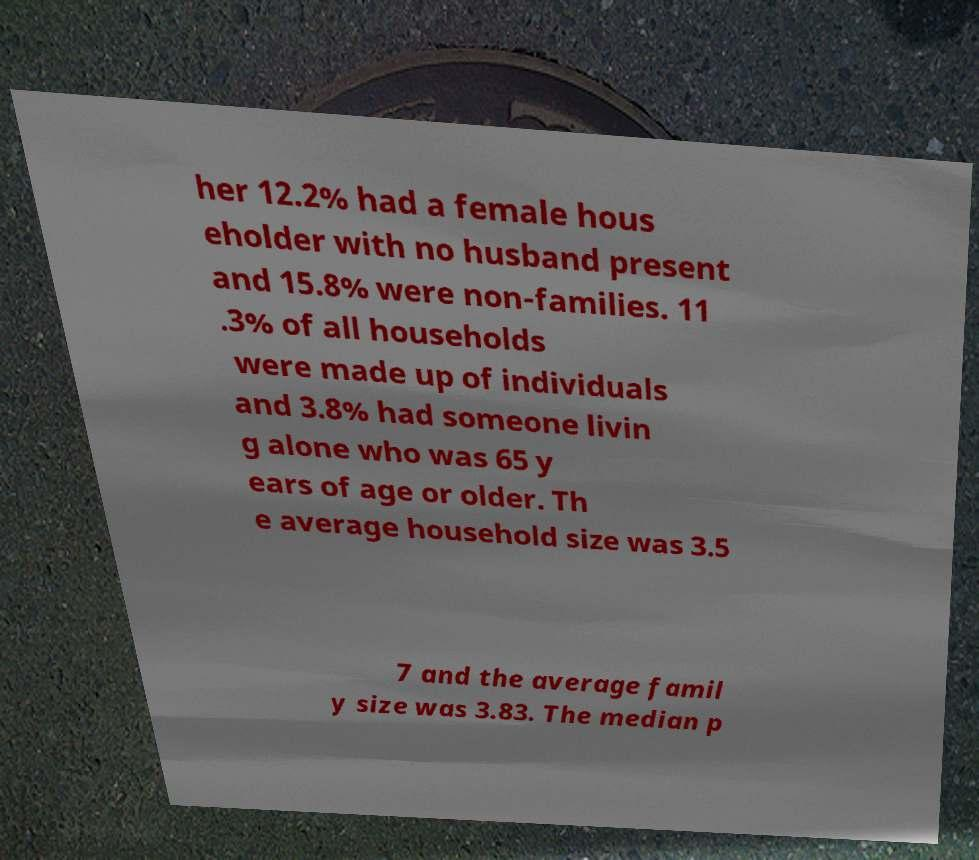What messages or text are displayed in this image? I need them in a readable, typed format. her 12.2% had a female hous eholder with no husband present and 15.8% were non-families. 11 .3% of all households were made up of individuals and 3.8% had someone livin g alone who was 65 y ears of age or older. Th e average household size was 3.5 7 and the average famil y size was 3.83. The median p 